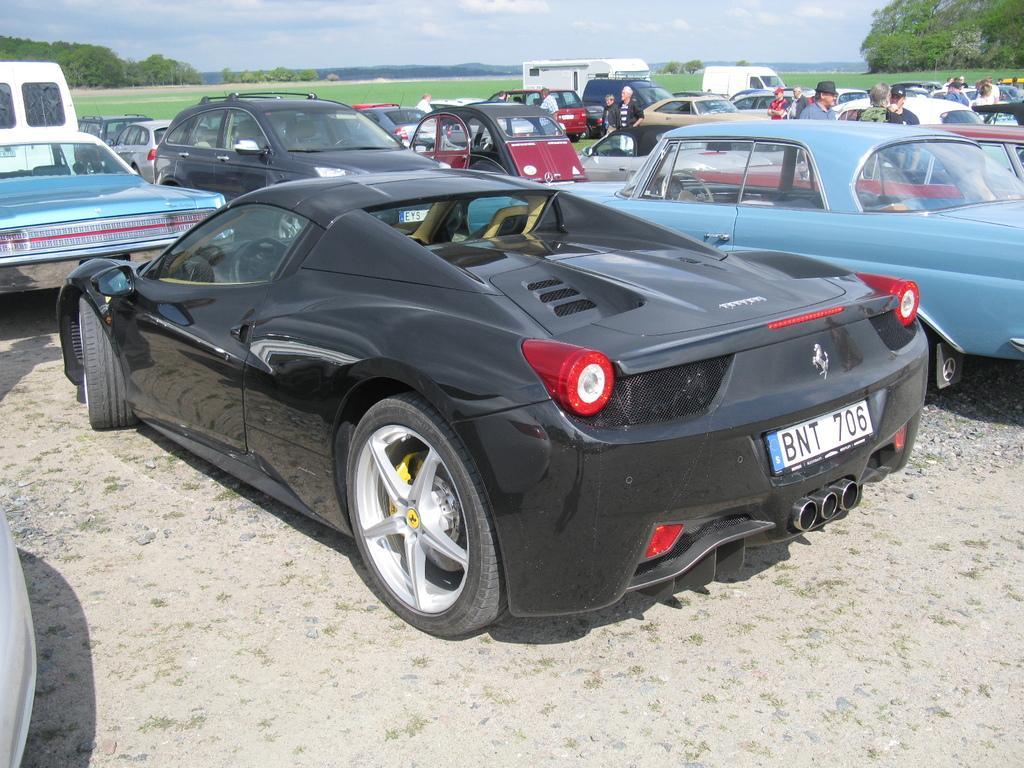Could you give a brief overview of what you see in this image? In this image I can see few vehicles. In front the vehicle is in black color, background I can see few persons standing, trees in green color and the sky is in white and blue color. 